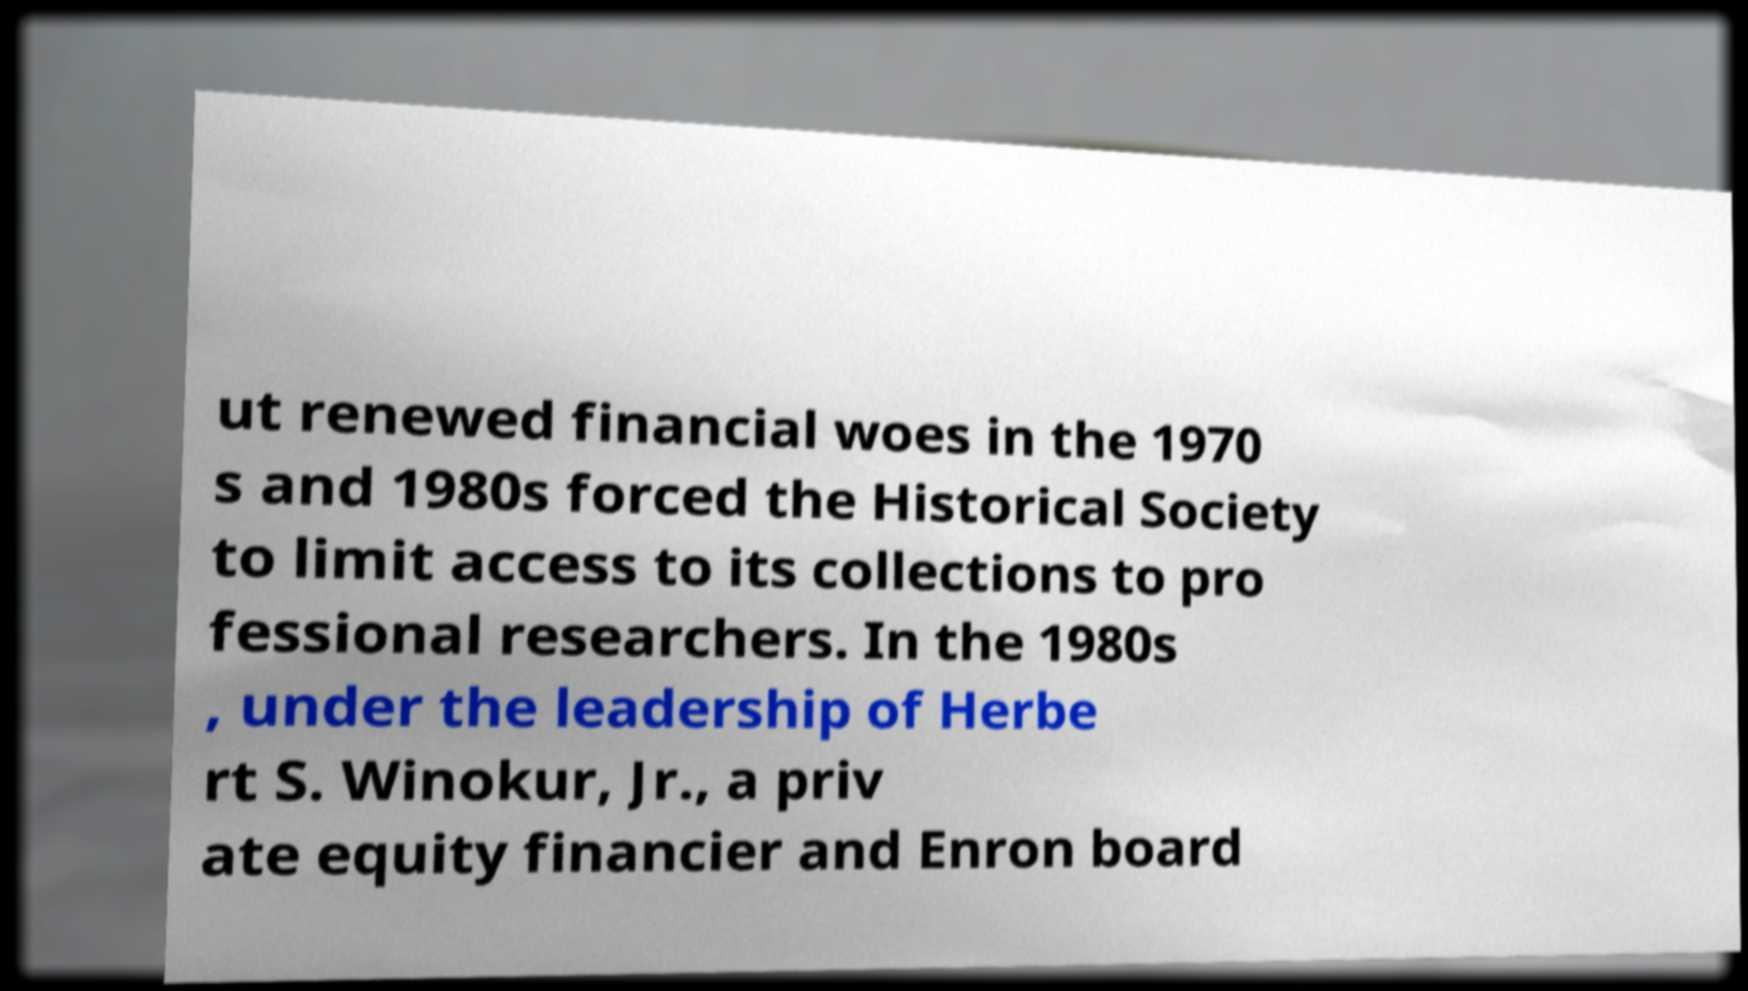What messages or text are displayed in this image? I need them in a readable, typed format. ut renewed financial woes in the 1970 s and 1980s forced the Historical Society to limit access to its collections to pro fessional researchers. In the 1980s , under the leadership of Herbe rt S. Winokur, Jr., a priv ate equity financier and Enron board 